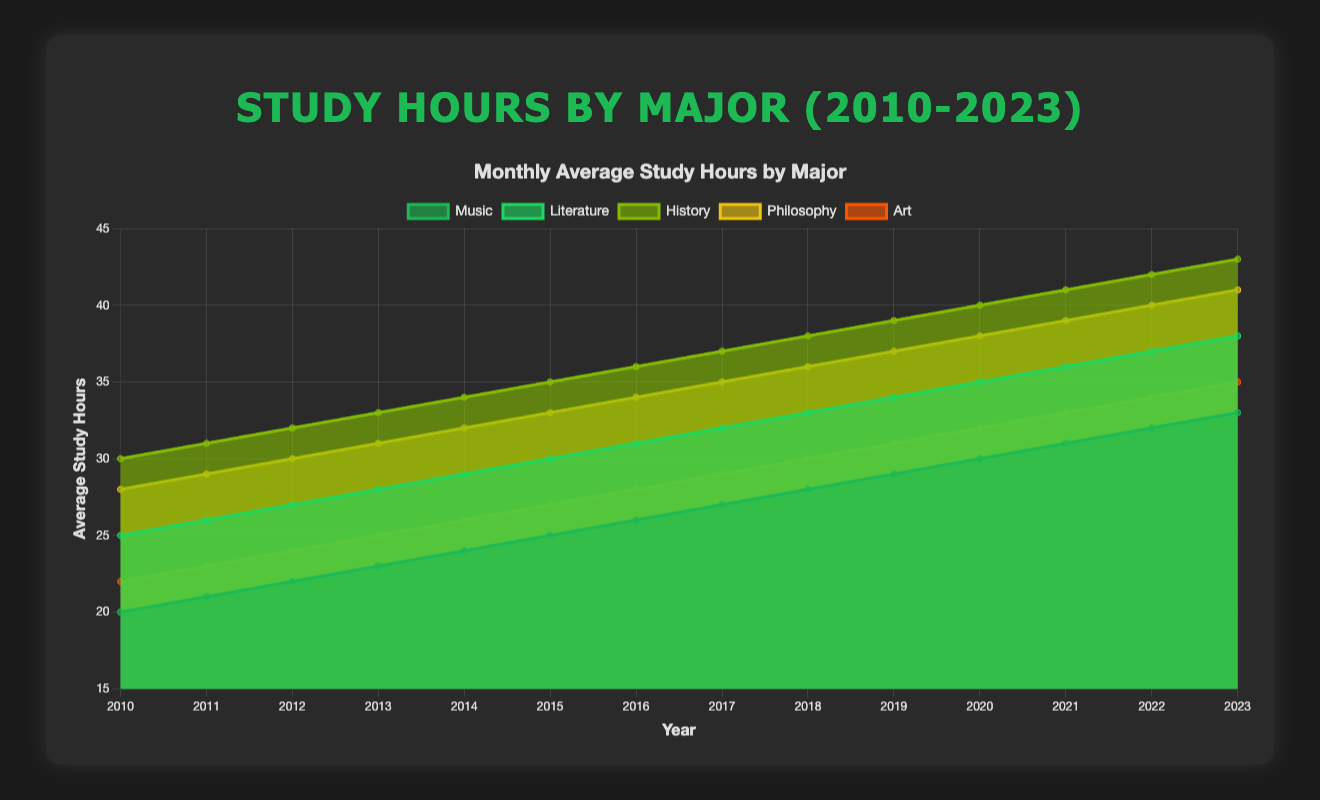What is the title of the chart? The title of the chart is prominently displayed at the top. It reads "Study Hours by Major (2010-2023)"
Answer: Study Hours by Major (2010-2023) Which major had the fewest study hours in 2010? The chart shows the study hours by major for each year. In 2010, the majors are listed, and Music has the fewest study hours at 20 hours.
Answer: Music By how much did the study hours for Philosophy increase from 2015 to 2020? In 2015, Philosophy had 33 hours, and this increased to 38 hours in 2020. The increase is calculated as 38 - 33 = 5 hours.
Answer: 5 hours Which major had the highest number of study hours in 2023? The chart shows study hours by major for each year, with History having the highest number of study hours in 2023 at 43 hours.
Answer: History Compare the average study hours of Music and Art in 2020. Which one is higher? In 2020, Music has 30 study hours and Art has 32 study hours. Art has higher average study hours than Music.
Answer: Art What is the trend for study hours of Literature from 2010 to 2023? Literature shows an increasing trend in study hours from 2010 with 25 hours to 2023 with 38 hours. The data points increment each year.
Answer: Increasing What is the overall increase in the study hours of Art from 2010 to 2023? In 2010, Art had 22 hours, and in 2023, it increased to 35 hours. The overall increase is 35 - 22 = 13 hours.
Answer: 13 hours Which major had a consistent increase in study hours each year? Each major shows consistent year-on-year increases. However, identifying one, History shows a consistent increase from 30 study hours in 2010 to 43 in 2023.
Answer: History Between which two consecutive years did Music majors see the largest increase in study hours? Observing the study hours of Music from year to year, the largest increase appears between 2018 (28 hours) and 2019 (29 hours), which is an increase of 1 hour.
Answer: Between 2018 and 2019 If we sum up the study hours for 2023 for all the listed majors, what is the total? Adding up the study hours for all majors in 2023 results in Music: 33, Literature: 38, History: 43, Philosophy: 41, and Art: 35. The sum is 33 + 38 + 43 + 41 + 35 = 190.
Answer: 190 